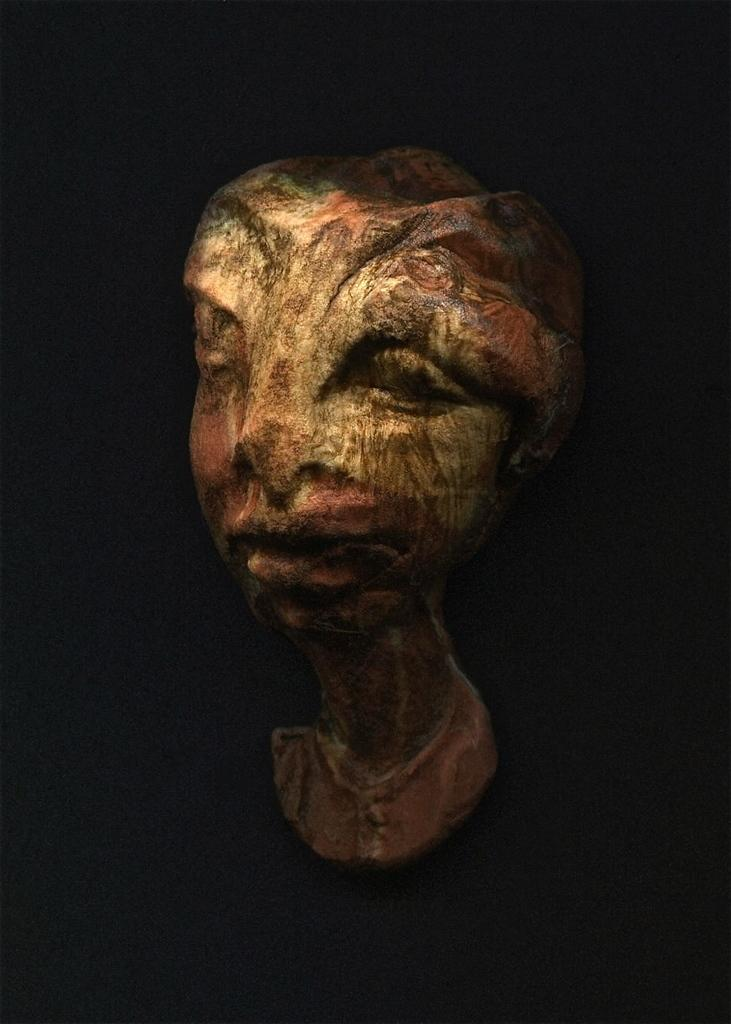What is the main subject of the image? There is a sculpture in the middle of the image. How many servants are attending to the sculpture in the image? There is no mention of servants in the image, as the only fact provided is about the sculpture. 